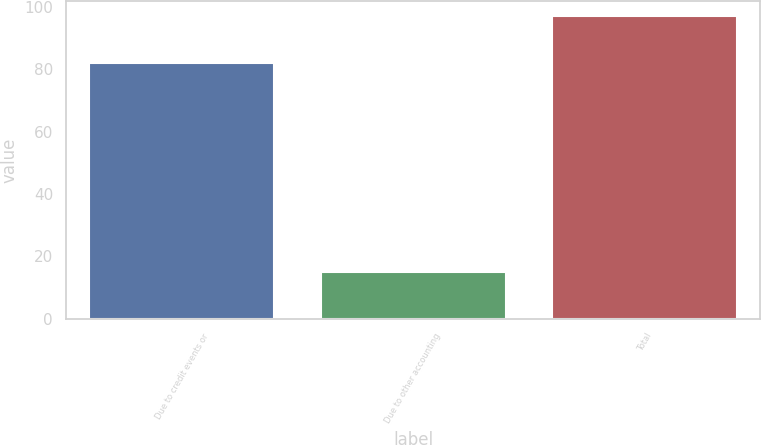<chart> <loc_0><loc_0><loc_500><loc_500><bar_chart><fcel>Due to credit events or<fcel>Due to other accounting<fcel>Total<nl><fcel>82<fcel>15<fcel>97<nl></chart> 